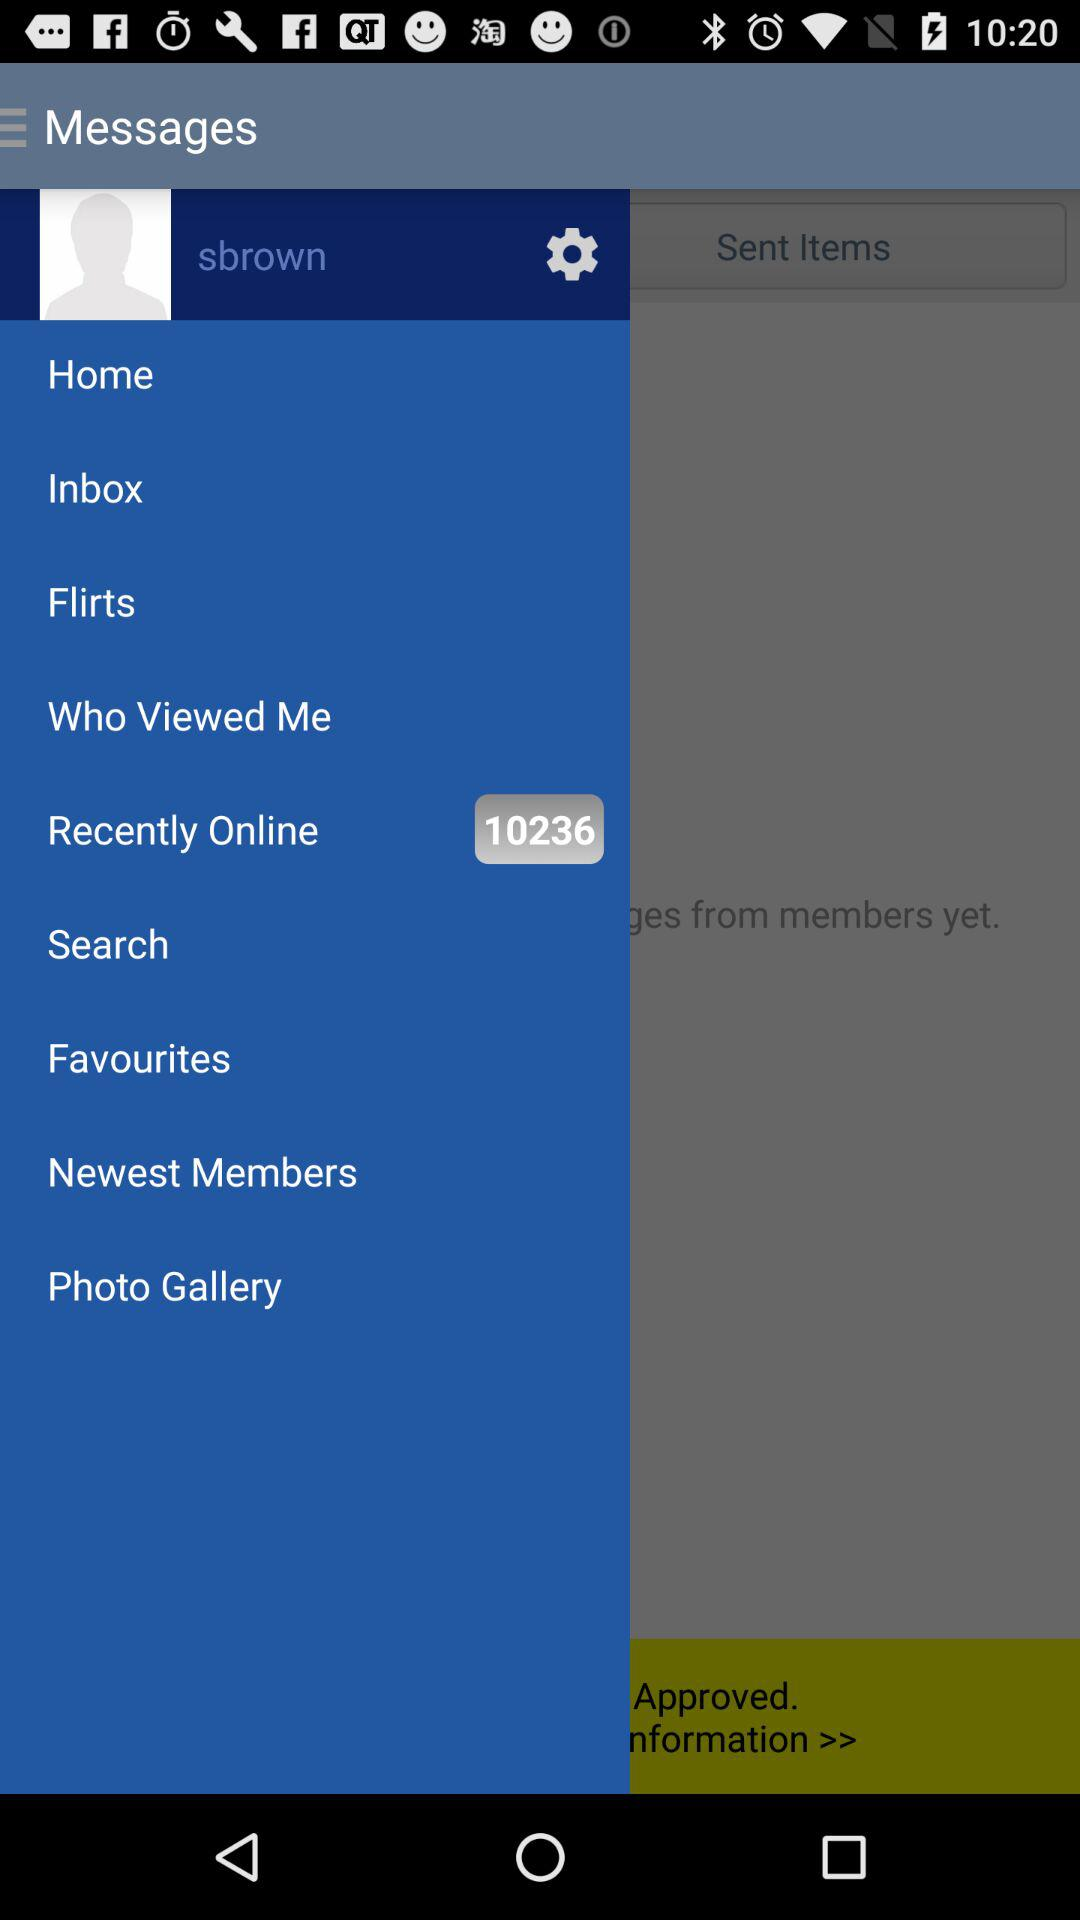How many people are "Recently Online"? The people are 10236. 